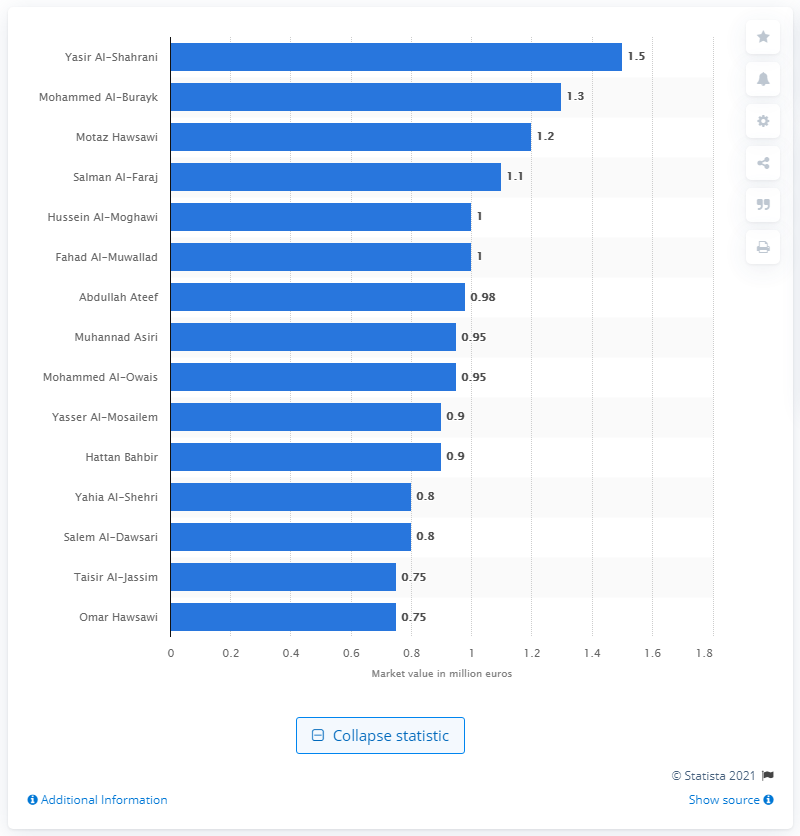Give some essential details in this illustration. Yasir Al-Shahrani's market value was 1.5 million dollars. Yasir Al-Shahrani was named the most valuable player at the 2018 FIFA World Cup. 